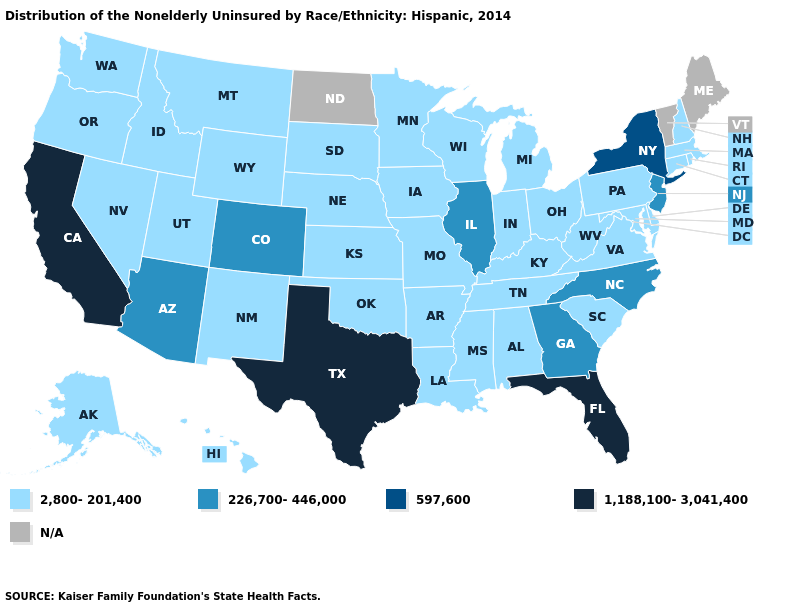Name the states that have a value in the range 226,700-446,000?
Keep it brief. Arizona, Colorado, Georgia, Illinois, New Jersey, North Carolina. What is the value of Idaho?
Be succinct. 2,800-201,400. What is the highest value in states that border Wyoming?
Concise answer only. 226,700-446,000. Does Colorado have the lowest value in the West?
Concise answer only. No. Does Texas have the highest value in the USA?
Write a very short answer. Yes. Name the states that have a value in the range 226,700-446,000?
Keep it brief. Arizona, Colorado, Georgia, Illinois, New Jersey, North Carolina. What is the value of New Hampshire?
Write a very short answer. 2,800-201,400. Does Rhode Island have the lowest value in the Northeast?
Keep it brief. Yes. Name the states that have a value in the range 1,188,100-3,041,400?
Answer briefly. California, Florida, Texas. Name the states that have a value in the range 1,188,100-3,041,400?
Give a very brief answer. California, Florida, Texas. Does the map have missing data?
Give a very brief answer. Yes. What is the value of South Carolina?
Be succinct. 2,800-201,400. What is the value of Mississippi?
Keep it brief. 2,800-201,400. 